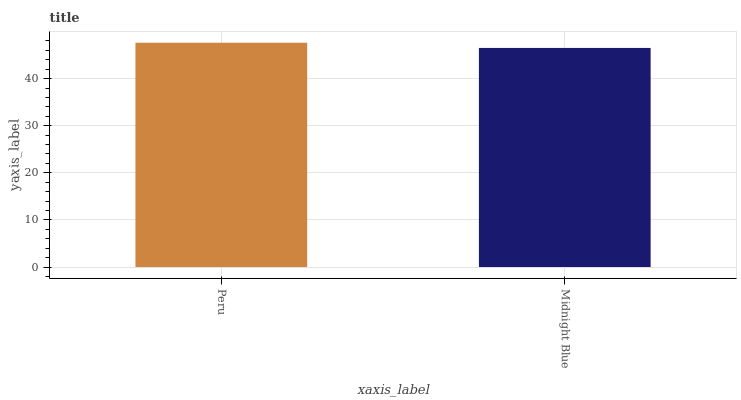Is Midnight Blue the minimum?
Answer yes or no. Yes. Is Peru the maximum?
Answer yes or no. Yes. Is Midnight Blue the maximum?
Answer yes or no. No. Is Peru greater than Midnight Blue?
Answer yes or no. Yes. Is Midnight Blue less than Peru?
Answer yes or no. Yes. Is Midnight Blue greater than Peru?
Answer yes or no. No. Is Peru less than Midnight Blue?
Answer yes or no. No. Is Peru the high median?
Answer yes or no. Yes. Is Midnight Blue the low median?
Answer yes or no. Yes. Is Midnight Blue the high median?
Answer yes or no. No. Is Peru the low median?
Answer yes or no. No. 